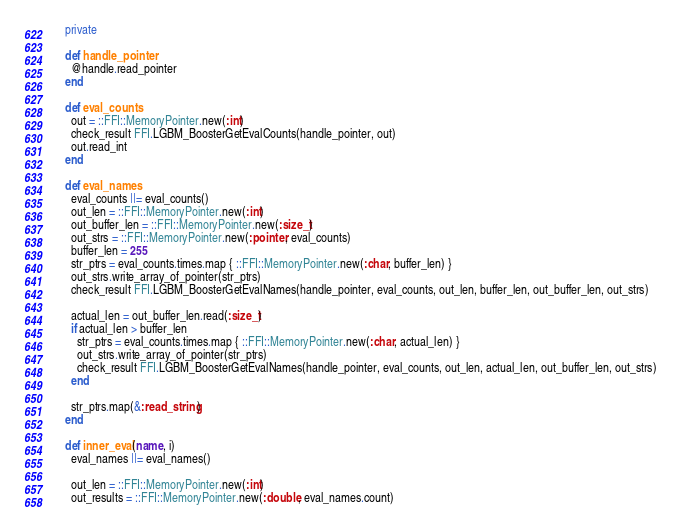Convert code to text. <code><loc_0><loc_0><loc_500><loc_500><_Ruby_>    private

    def handle_pointer
      @handle.read_pointer
    end

    def eval_counts
      out = ::FFI::MemoryPointer.new(:int)
      check_result FFI.LGBM_BoosterGetEvalCounts(handle_pointer, out)
      out.read_int
    end

    def eval_names
      eval_counts ||= eval_counts()
      out_len = ::FFI::MemoryPointer.new(:int)
      out_buffer_len = ::FFI::MemoryPointer.new(:size_t)
      out_strs = ::FFI::MemoryPointer.new(:pointer, eval_counts)
      buffer_len = 255
      str_ptrs = eval_counts.times.map { ::FFI::MemoryPointer.new(:char, buffer_len) }
      out_strs.write_array_of_pointer(str_ptrs)
      check_result FFI.LGBM_BoosterGetEvalNames(handle_pointer, eval_counts, out_len, buffer_len, out_buffer_len, out_strs)

      actual_len = out_buffer_len.read(:size_t)
      if actual_len > buffer_len
        str_ptrs = eval_counts.times.map { ::FFI::MemoryPointer.new(:char, actual_len) }
        out_strs.write_array_of_pointer(str_ptrs)
        check_result FFI.LGBM_BoosterGetEvalNames(handle_pointer, eval_counts, out_len, actual_len, out_buffer_len, out_strs)
      end

      str_ptrs.map(&:read_string)
    end

    def inner_eval(name, i)
      eval_names ||= eval_names()

      out_len = ::FFI::MemoryPointer.new(:int)
      out_results = ::FFI::MemoryPointer.new(:double, eval_names.count)</code> 